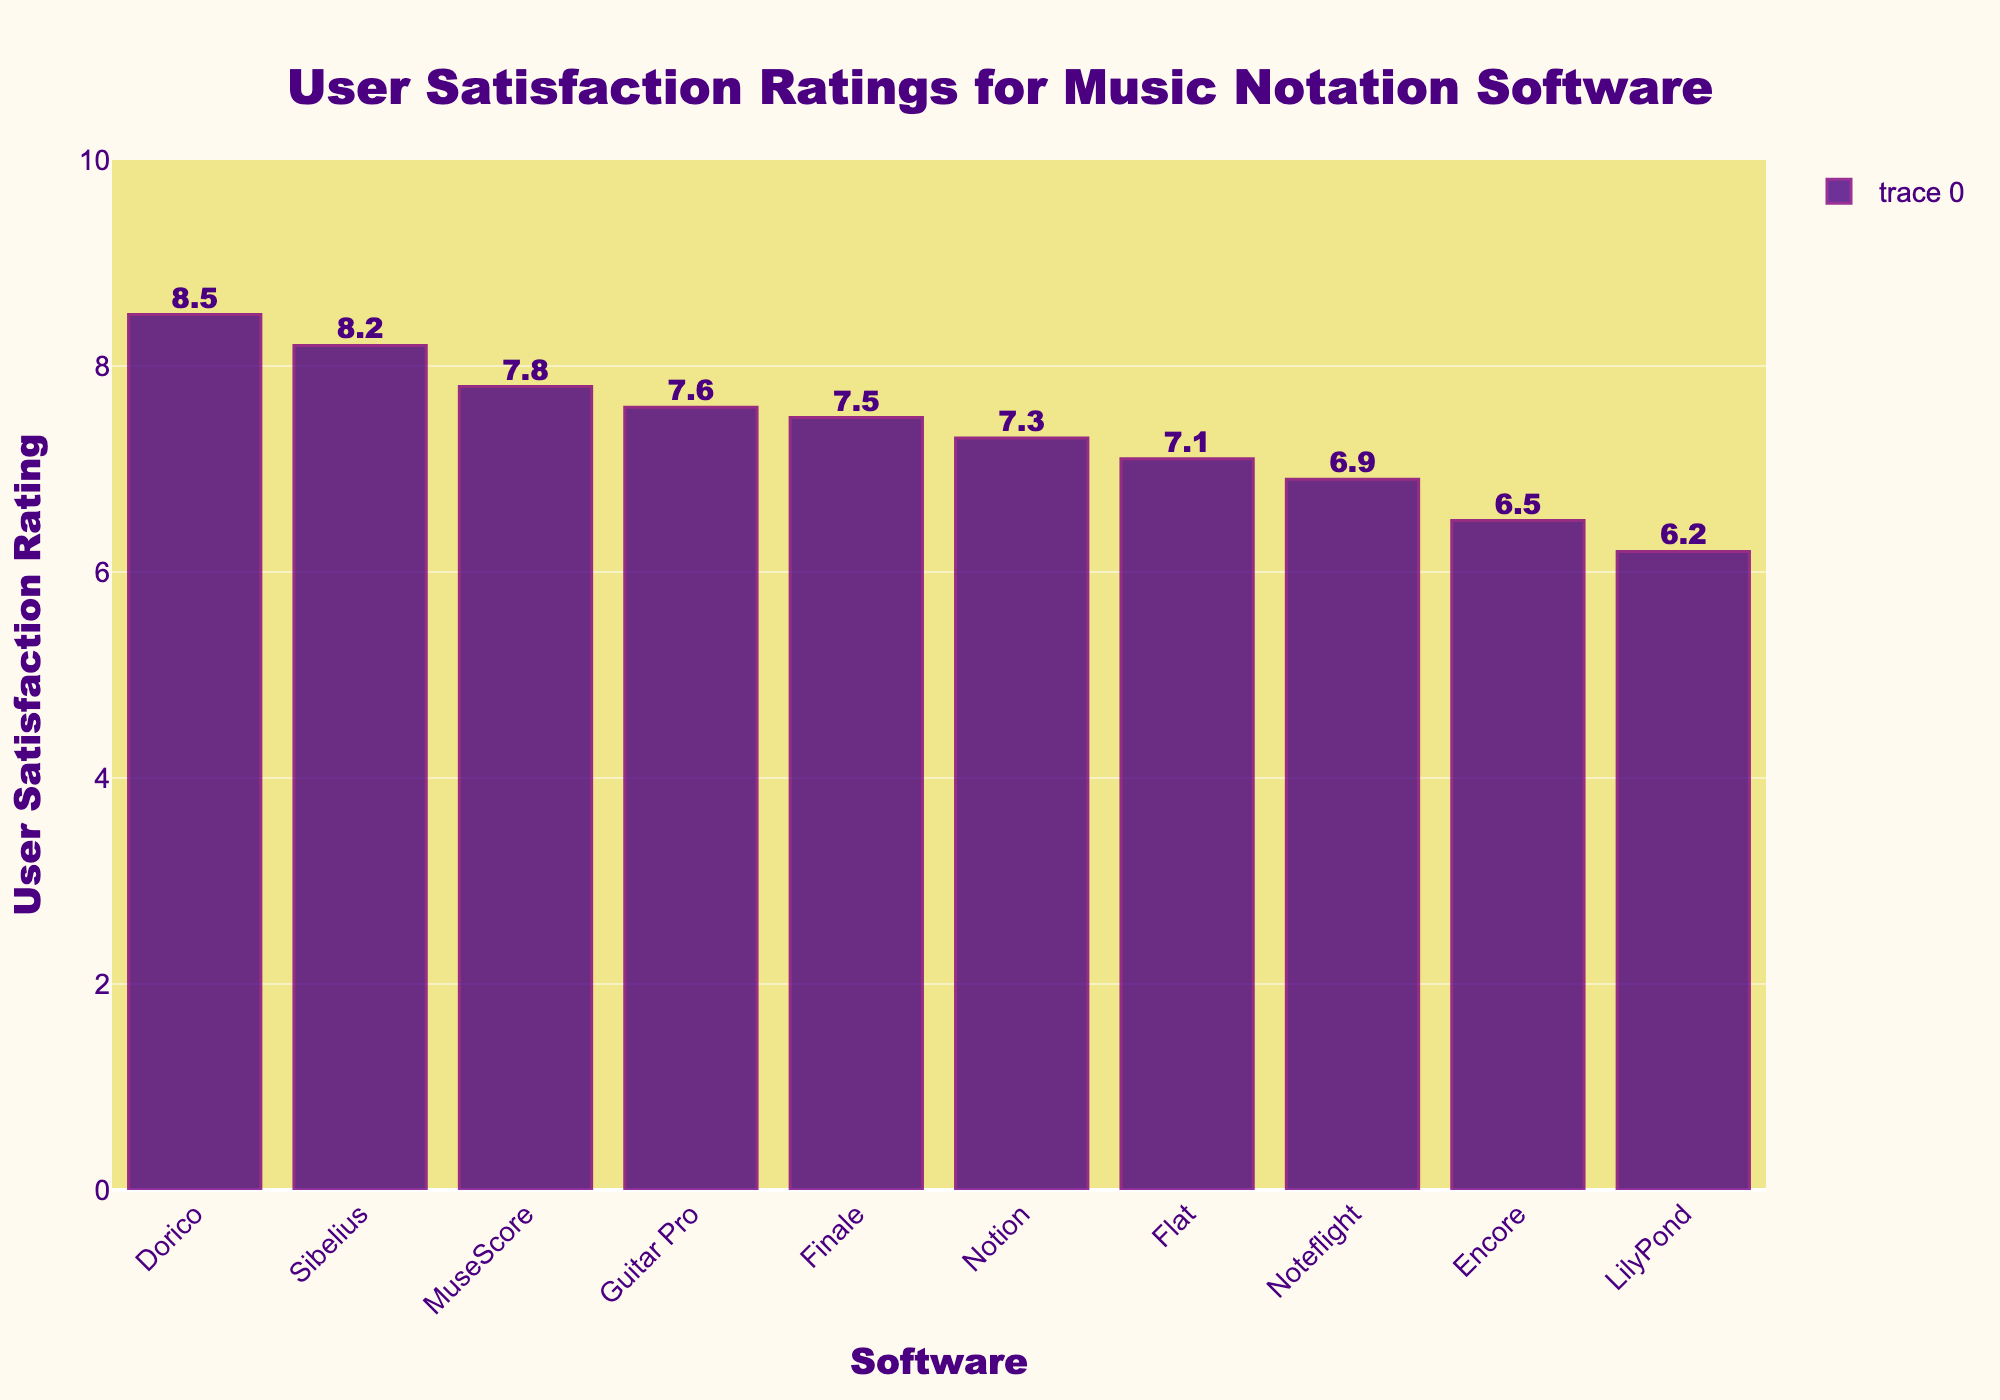Which software has the highest user satisfaction rating? The tallest bar in the chart represents the software with the highest user satisfaction rating. Looking at the height of the bars, Dorico has the tallest bar.
Answer: Dorico What is the difference in user satisfaction rating between MuseScore and Sibelius? MuseScore has a user satisfaction rating of 7.8 while Sibelius has 8.2. The difference is calculated by subtracting the lower rating from the higher rating: 8.2 - 7.8 is 0.4.
Answer: 0.4 Which software has a lower satisfaction rating, Noteflight or Flat? By comparing the heights of the bars corresponding to Noteflight and Flat, we see that Noteflight has a lower rating of 6.9 compared to Flat's 7.1.
Answer: Noteflight What is the average user satisfaction rating for all the software? Add together all the user satisfaction ratings: 7.8 + 8.2 + 7.5 + 8.5 + 6.9 + 7.1 + 6.2 + 6.5 + 7.3 + 7.6 = 73.6. Then divide by the number of software (10): 73.6 / 10 = 7.36.
Answer: 7.36 How many software have a user satisfaction rating of 7 or higher? Count the bars with a satisfaction rating of 7 or higher: MuseScore, Sibelius, Finale, Dorico, Flat, Notion, Guitar Pro (7 in total).
Answer: 7 Which software has the closest user satisfaction rating to MuseScore? MuseScore has a rating of 7.8, and the closest rating to this is 7.6 (Guitar Pro), as it is only 0.2 points away.
Answer: Guitar Pro What is the combined user satisfaction rating of LilyPond and Encore? The satisfaction rating of LilyPond is 6.2 and Encore is 6.5. Adding them yields 6.2 + 6.5 = 12.7.
Answer: 12.7 Is there any software that has a user satisfaction rating above 8? By examining the heights of the bars, we see that Sibelius (8.2) and Dorico (8.5) have ratings above 8.
Answer: Yes How much higher is Dorico's user satisfaction rating compared to the average rating? First, calculate the average rating (7.36). Then, find the difference between Dorico's rating (8.5) and the average rating: 8.5 - 7.36 = 1.14.
Answer: 1.14 